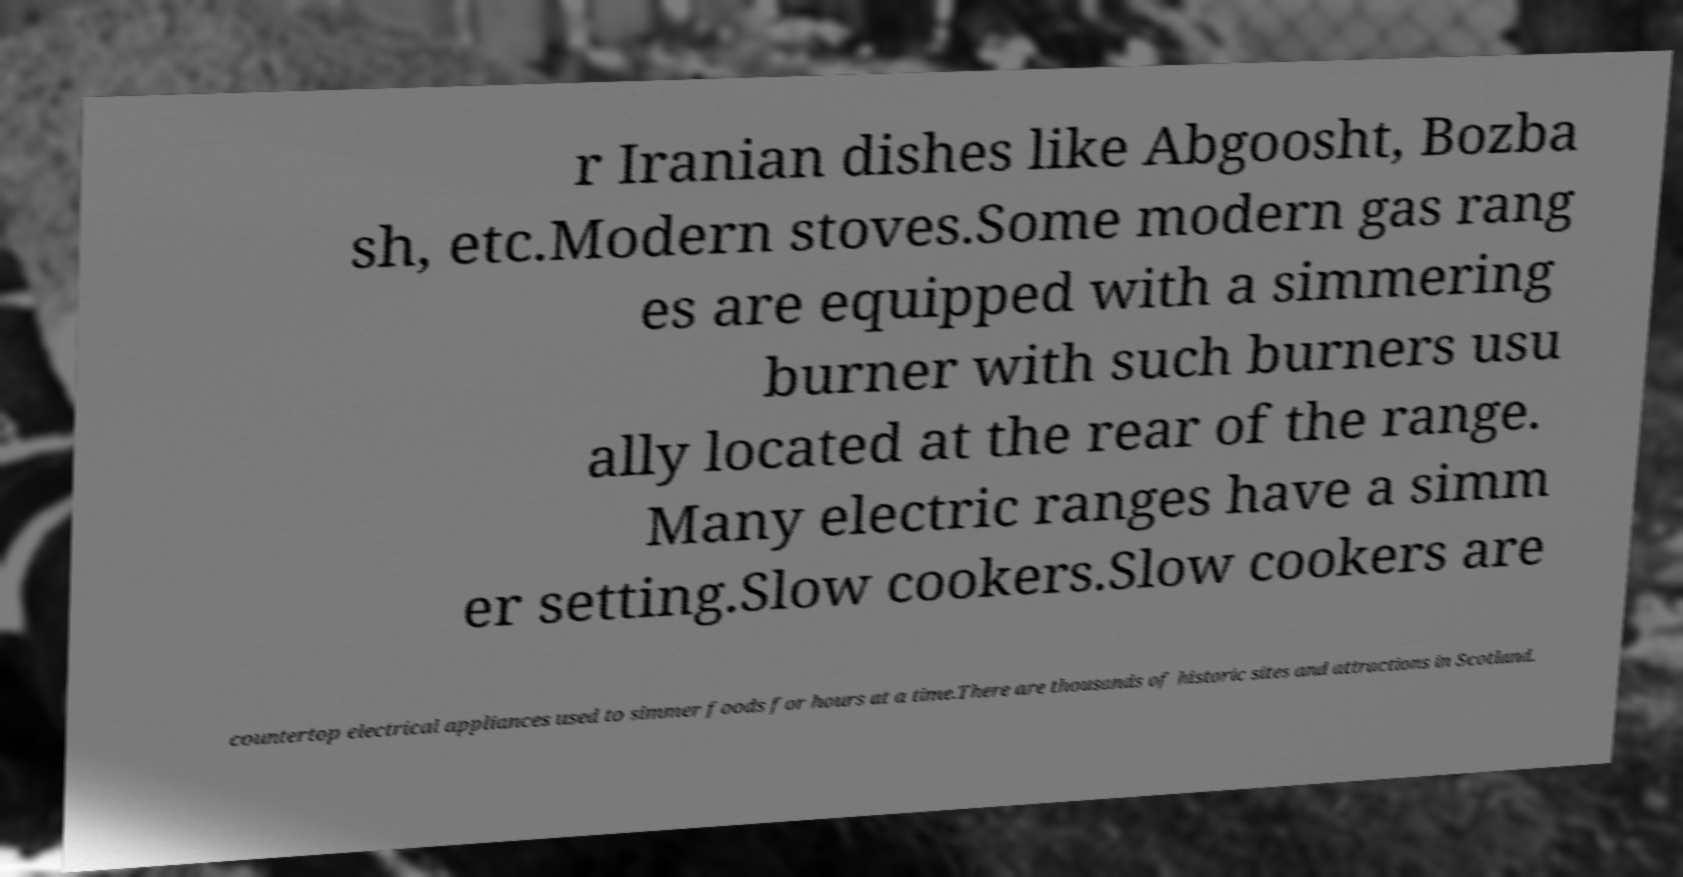What messages or text are displayed in this image? I need them in a readable, typed format. r Iranian dishes like Abgoosht, Bozba sh, etc.Modern stoves.Some modern gas rang es are equipped with a simmering burner with such burners usu ally located at the rear of the range. Many electric ranges have a simm er setting.Slow cookers.Slow cookers are countertop electrical appliances used to simmer foods for hours at a time.There are thousands of historic sites and attractions in Scotland. 